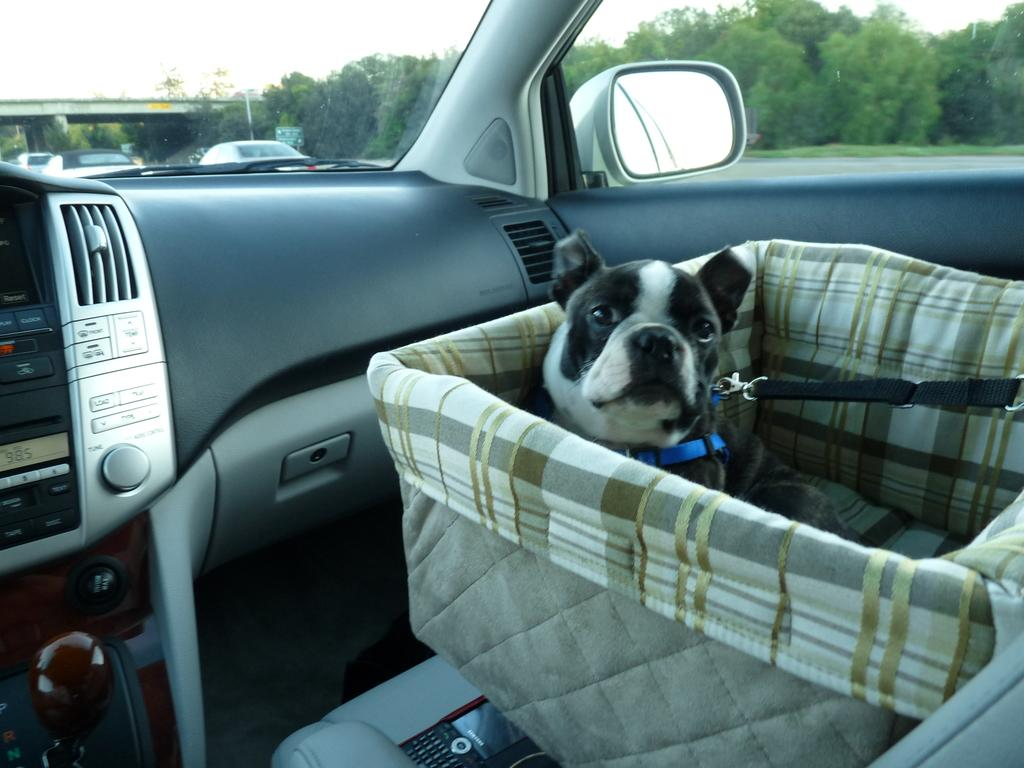What type of animal is in the image? There is a dog in the image. Where is the dog located? The dog is in a basket. What is the basket situated in? The basket is in a car. What can be seen in the background of the image? There is a bridge, vehicles, trees, and the sky visible in the background of the image. How many rods can be seen holding up the bridge in the image? There are no rods visible in the image; the bridge's structure is not described in the provided facts. What type of ducks are swimming in the car with the dog? There are no ducks present in the image; the only animal mentioned is the dog. 